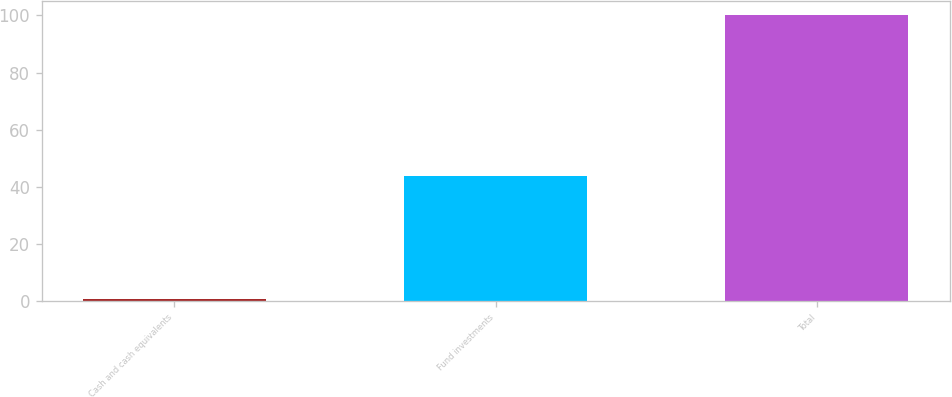Convert chart to OTSL. <chart><loc_0><loc_0><loc_500><loc_500><bar_chart><fcel>Cash and cash equivalents<fcel>Fund investments<fcel>Total<nl><fcel>0.7<fcel>43.7<fcel>100<nl></chart> 